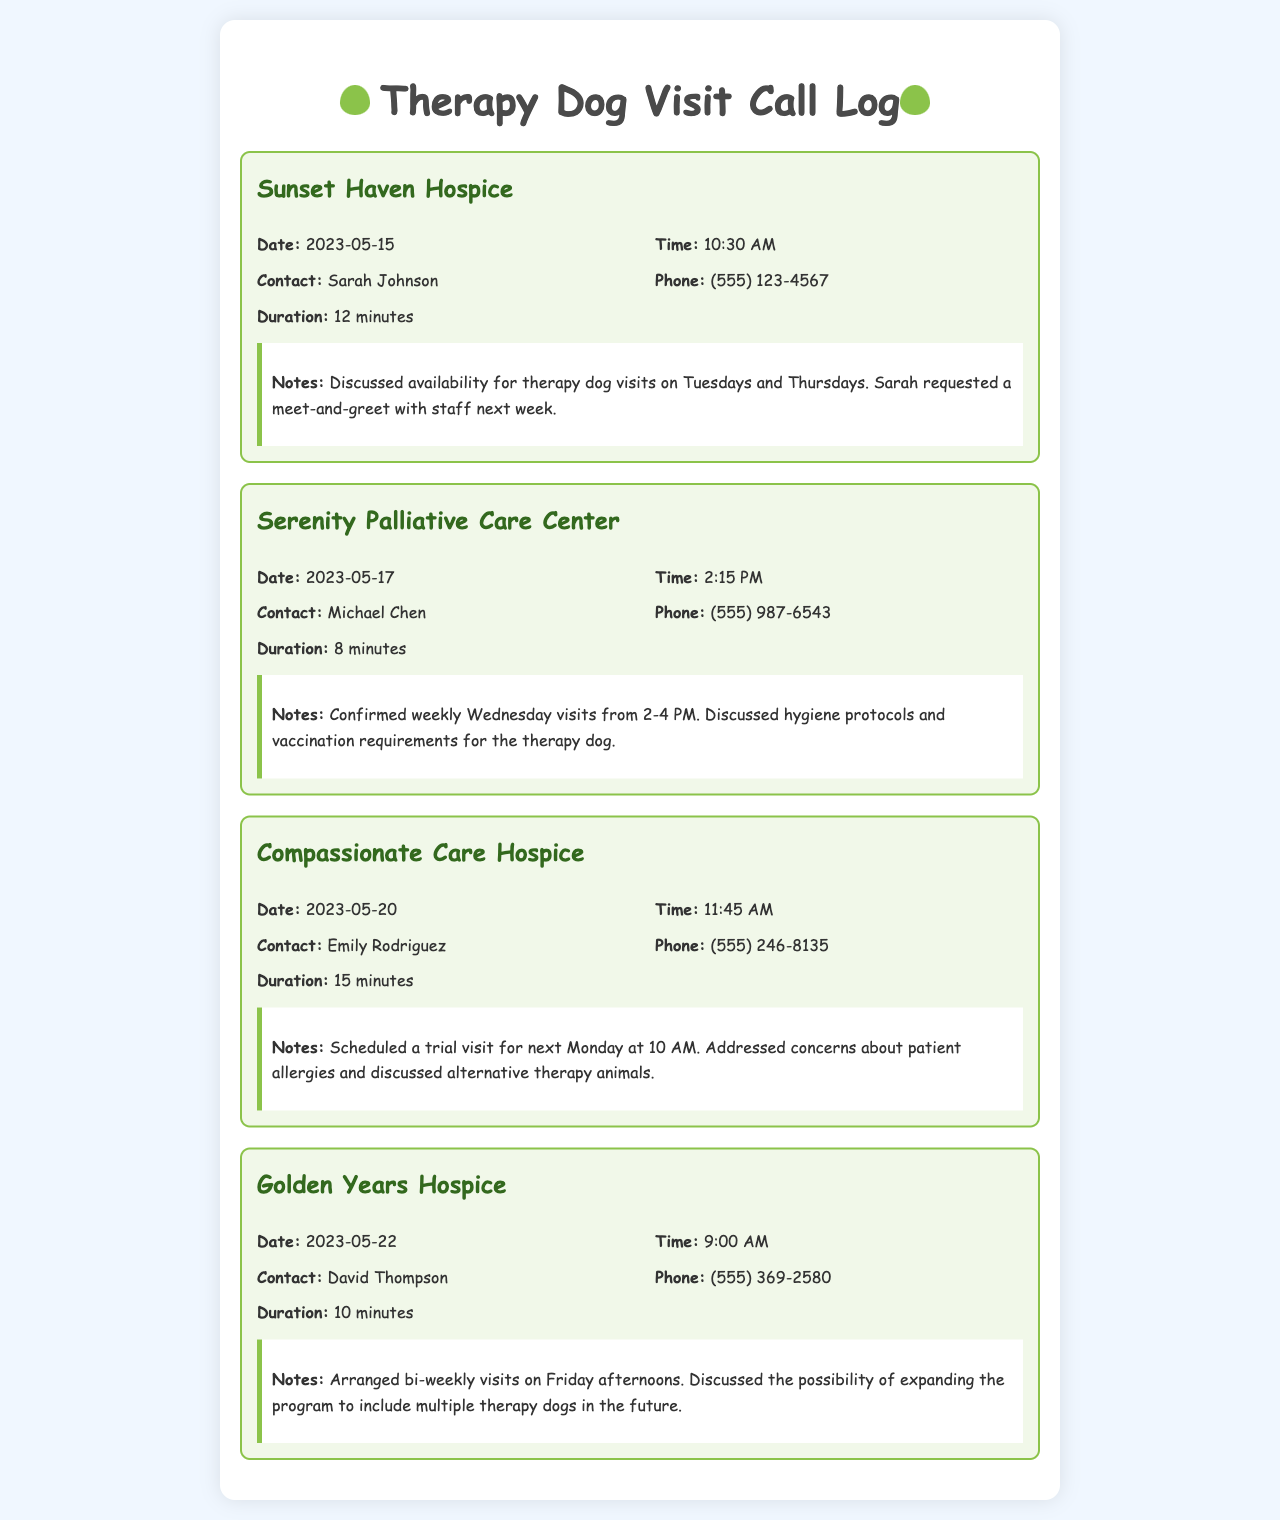What is the name of the first hospice facility contacted? The first facility contacted in the call log is indicated by the first entry.
Answer: Sunset Haven Hospice What date was the trial visit scheduled at Compassionate Care Hospice? The date for the trial visit is mentioned in the notes section of the Compassionate Care Hospice entry.
Answer: Next Monday Who is the contact at Serenity Palliative Care Center? The contact name is found in the call details for Serenity Palliative Care Center.
Answer: Michael Chen What time are the weekly visits confirmed for Serenity Palliative Care Center? The specific time for the weekly visits is stated in the notes section for Serenity Palliative Care Center.
Answer: 2-4 PM How long was the call with David Thompson from Golden Years Hospice? The duration of the call with David Thompson can be found in the call details section for Golden Years Hospice.
Answer: 10 minutes What was discussed regarding hygiene for the therapy dog? The discussion about hygiene protocols can be found in the notes for Serenity Palliative Care Center.
Answer: Hygiene protocols What frequency of visits was arranged for Golden Years Hospice? The frequency of visits is mentioned in the notes for Golden Years Hospice.
Answer: Bi-weekly What type of animals were discussed as alternatives at Compassionate Care Hospice? The alternative types of therapy animals are specified in the notes of the Compassionate Care Hospice entry.
Answer: Alternative therapy animals 